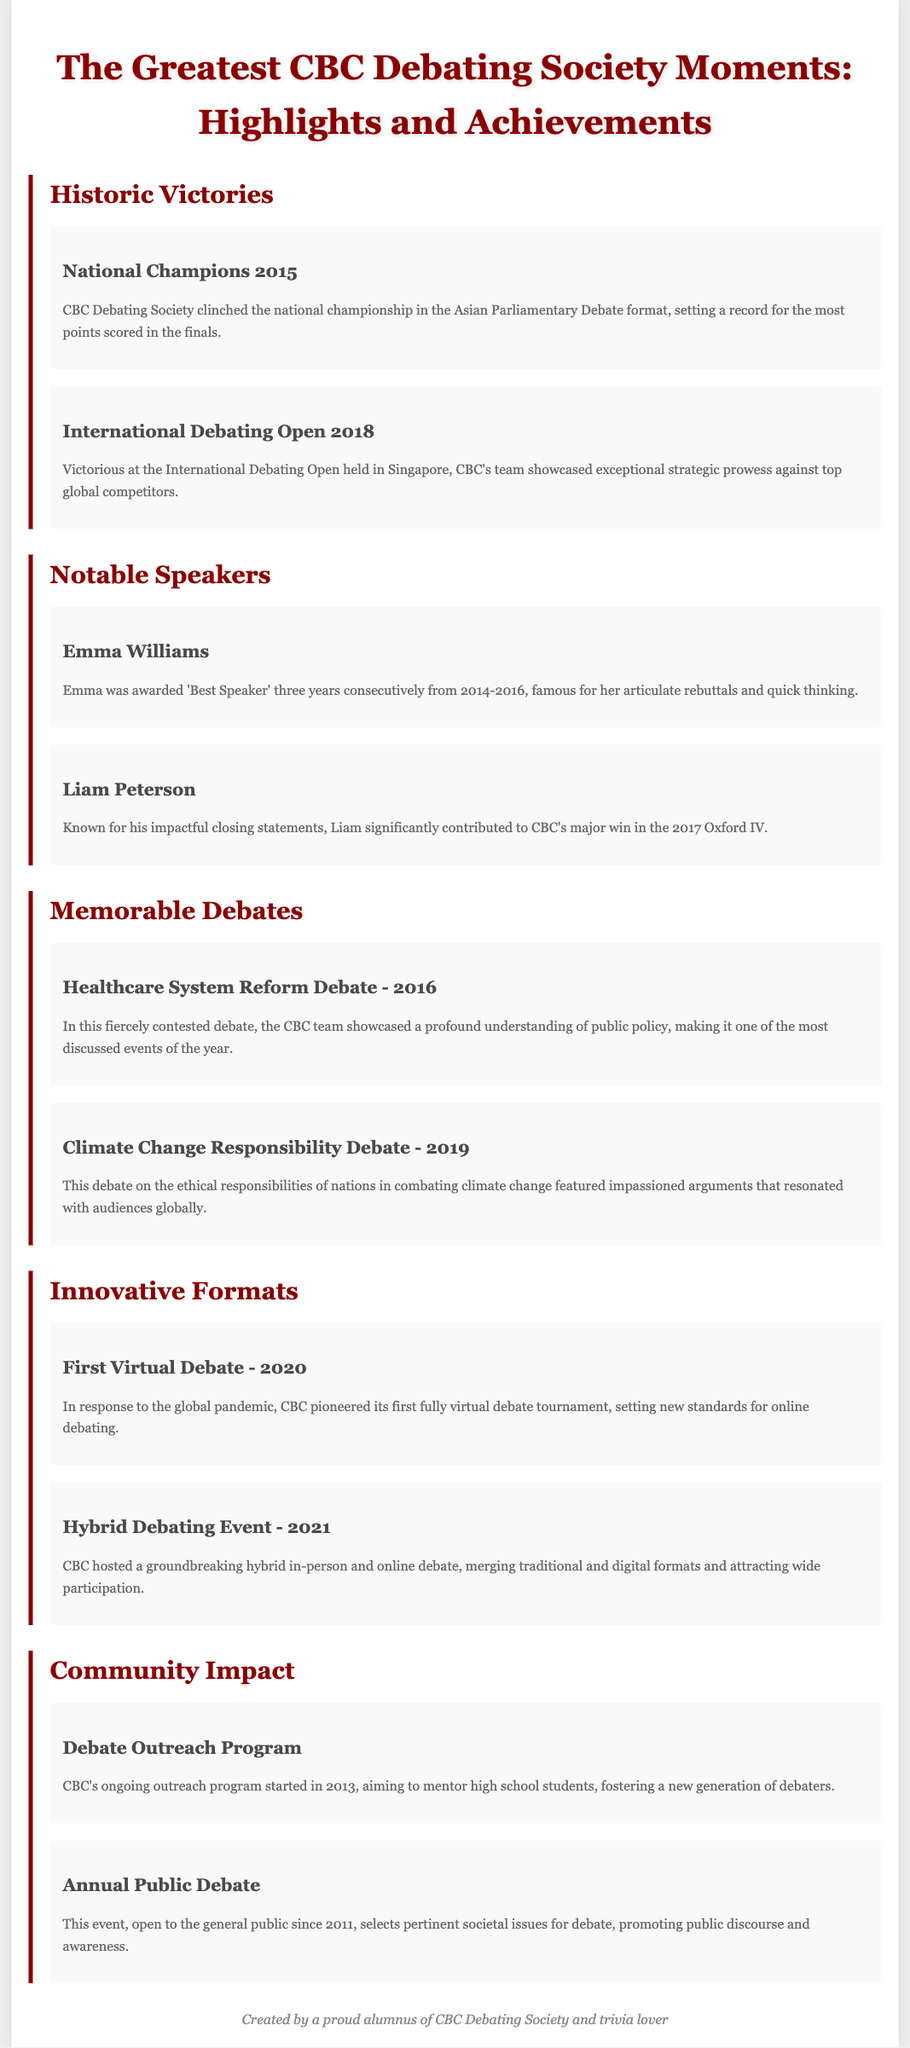What year did CBC win the national championship? CBC won the national championship in 2015.
Answer: 2015 Who was awarded 'Best Speaker' three years consecutively? Emma Williams was awarded 'Best Speaker' from 2014-2016.
Answer: Emma Williams What was the name of the debate showcasing public policy in 2016? The debate was about Healthcare System Reform.
Answer: Healthcare System Reform Debate What significant event did CBC host in response to the pandemic? CBC pioneered its first fully virtual debate tournament.
Answer: First Virtual Debate When did CBC's ongoing outreach program start? The outreach program started in 2013.
Answer: 2013 Which prestigious event featured Liam Peterson's impactful closing statements? Liam contributed significantly to CBC's win in the 2017 Oxford IV.
Answer: 2017 Oxford IV What new debating standard did CBC set in 2020? CBC set new standards for online debating with the first fully virtual debate.
Answer: First fully virtual debate What type of debate event was hosted by CBC in 2021? CBC hosted a groundbreaking hybrid in-person and online debate.
Answer: Hybrid Debating Event 